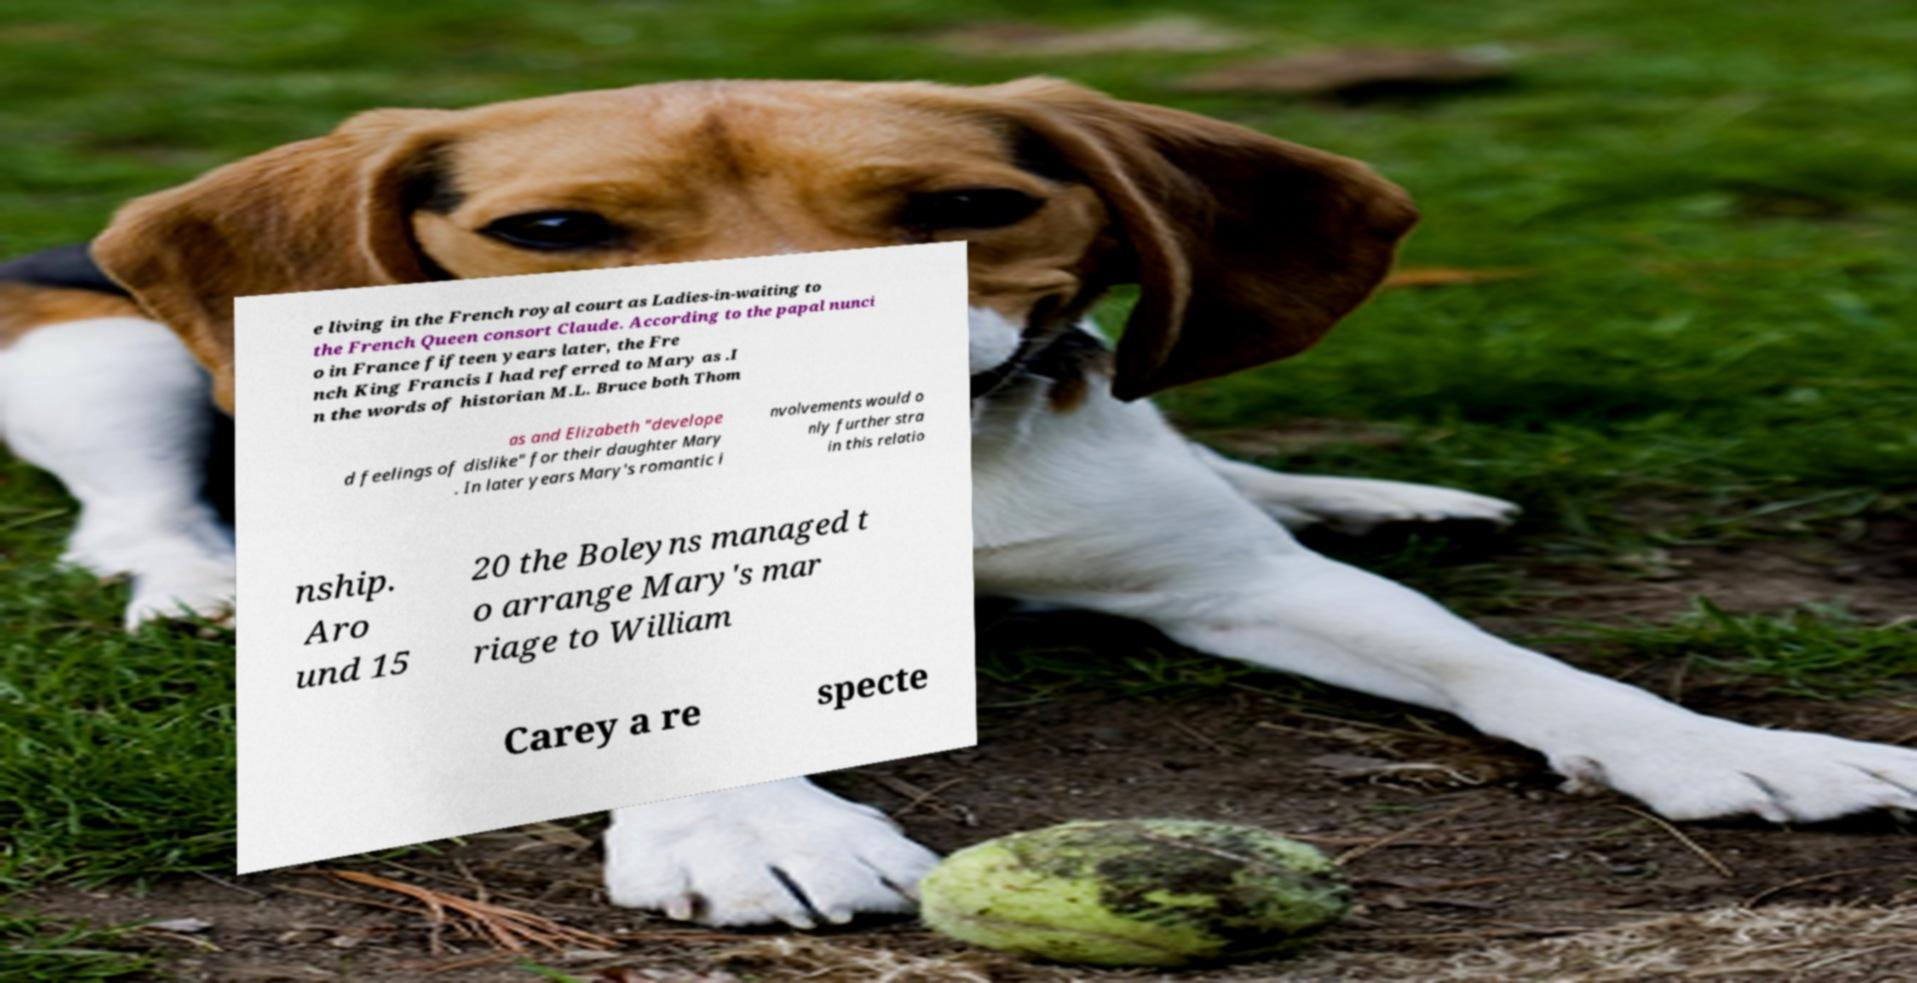There's text embedded in this image that I need extracted. Can you transcribe it verbatim? e living in the French royal court as Ladies-in-waiting to the French Queen consort Claude. According to the papal nunci o in France fifteen years later, the Fre nch King Francis I had referred to Mary as .I n the words of historian M.L. Bruce both Thom as and Elizabeth "develope d feelings of dislike" for their daughter Mary . In later years Mary's romantic i nvolvements would o nly further stra in this relatio nship. Aro und 15 20 the Boleyns managed t o arrange Mary's mar riage to William Carey a re specte 